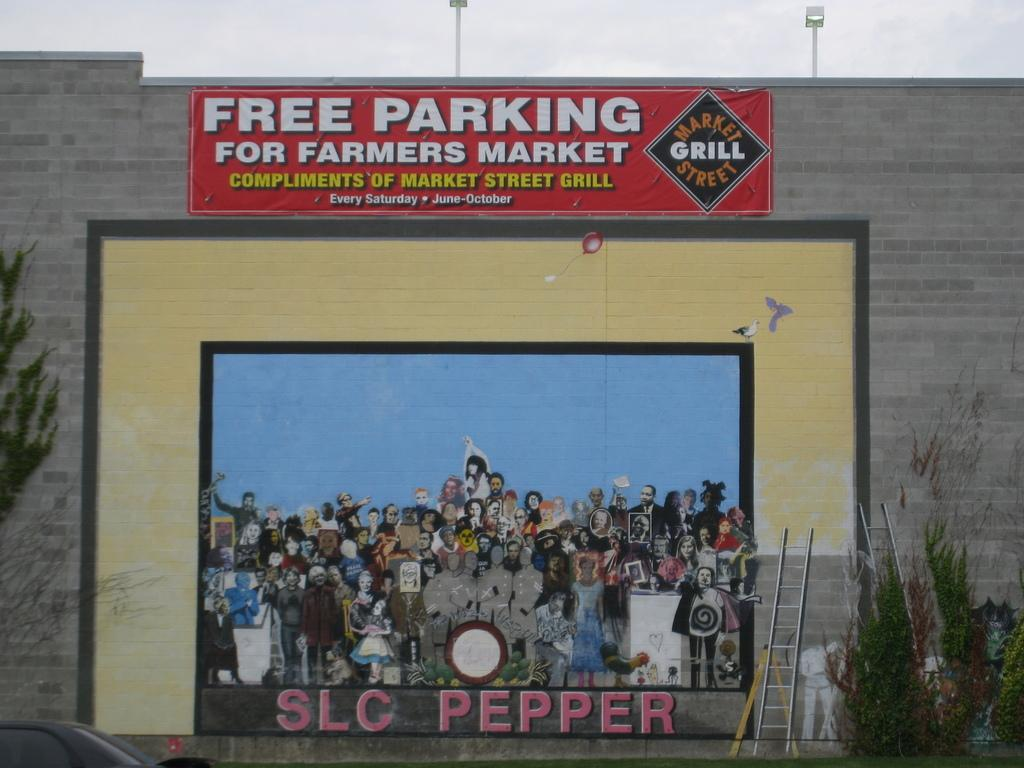<image>
Summarize the visual content of the image. A painting on the outside wall of a building with a sign for free parking above it. 